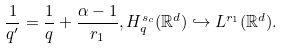<formula> <loc_0><loc_0><loc_500><loc_500>\frac { 1 } { q ^ { \prime } } = \frac { 1 } { q } + \frac { \alpha - 1 } { r _ { 1 } } , H ^ { s _ { c } } _ { q } ( \mathbb { R } ^ { d } ) \hookrightarrow L ^ { r _ { 1 } } ( \mathbb { R } ^ { d } ) .</formula> 